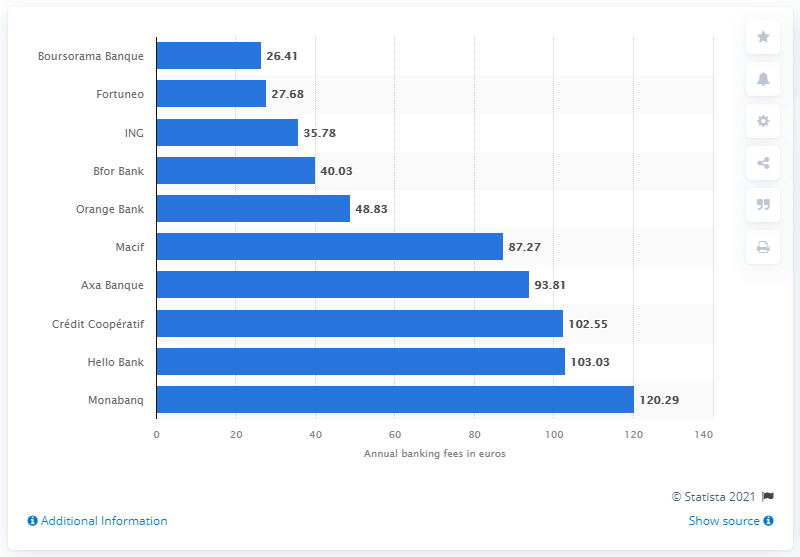Indicate a few pertinent items in this graphic. Boursorama Banque was the most affordable bank in France in 2020. 